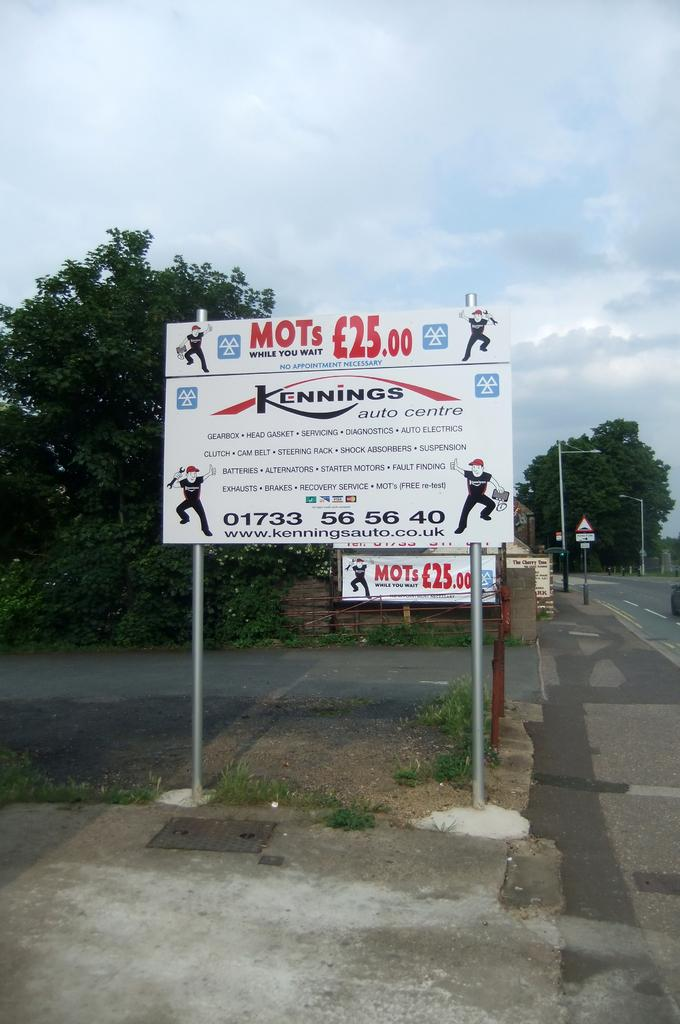<image>
Summarize the visual content of the image. Large sign on two metal poles that read "MOTs While you wait". 